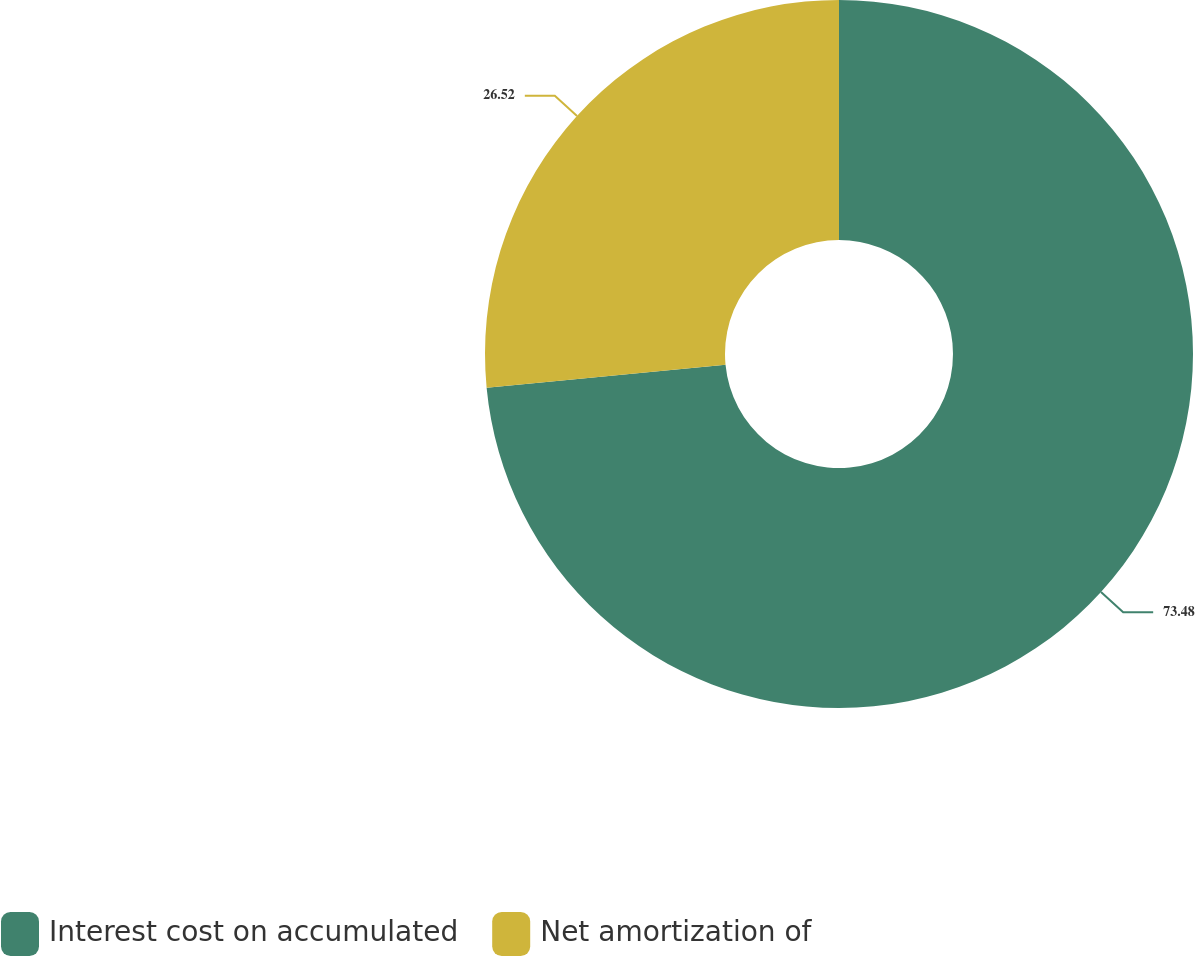Convert chart. <chart><loc_0><loc_0><loc_500><loc_500><pie_chart><fcel>Interest cost on accumulated<fcel>Net amortization of<nl><fcel>73.48%<fcel>26.52%<nl></chart> 